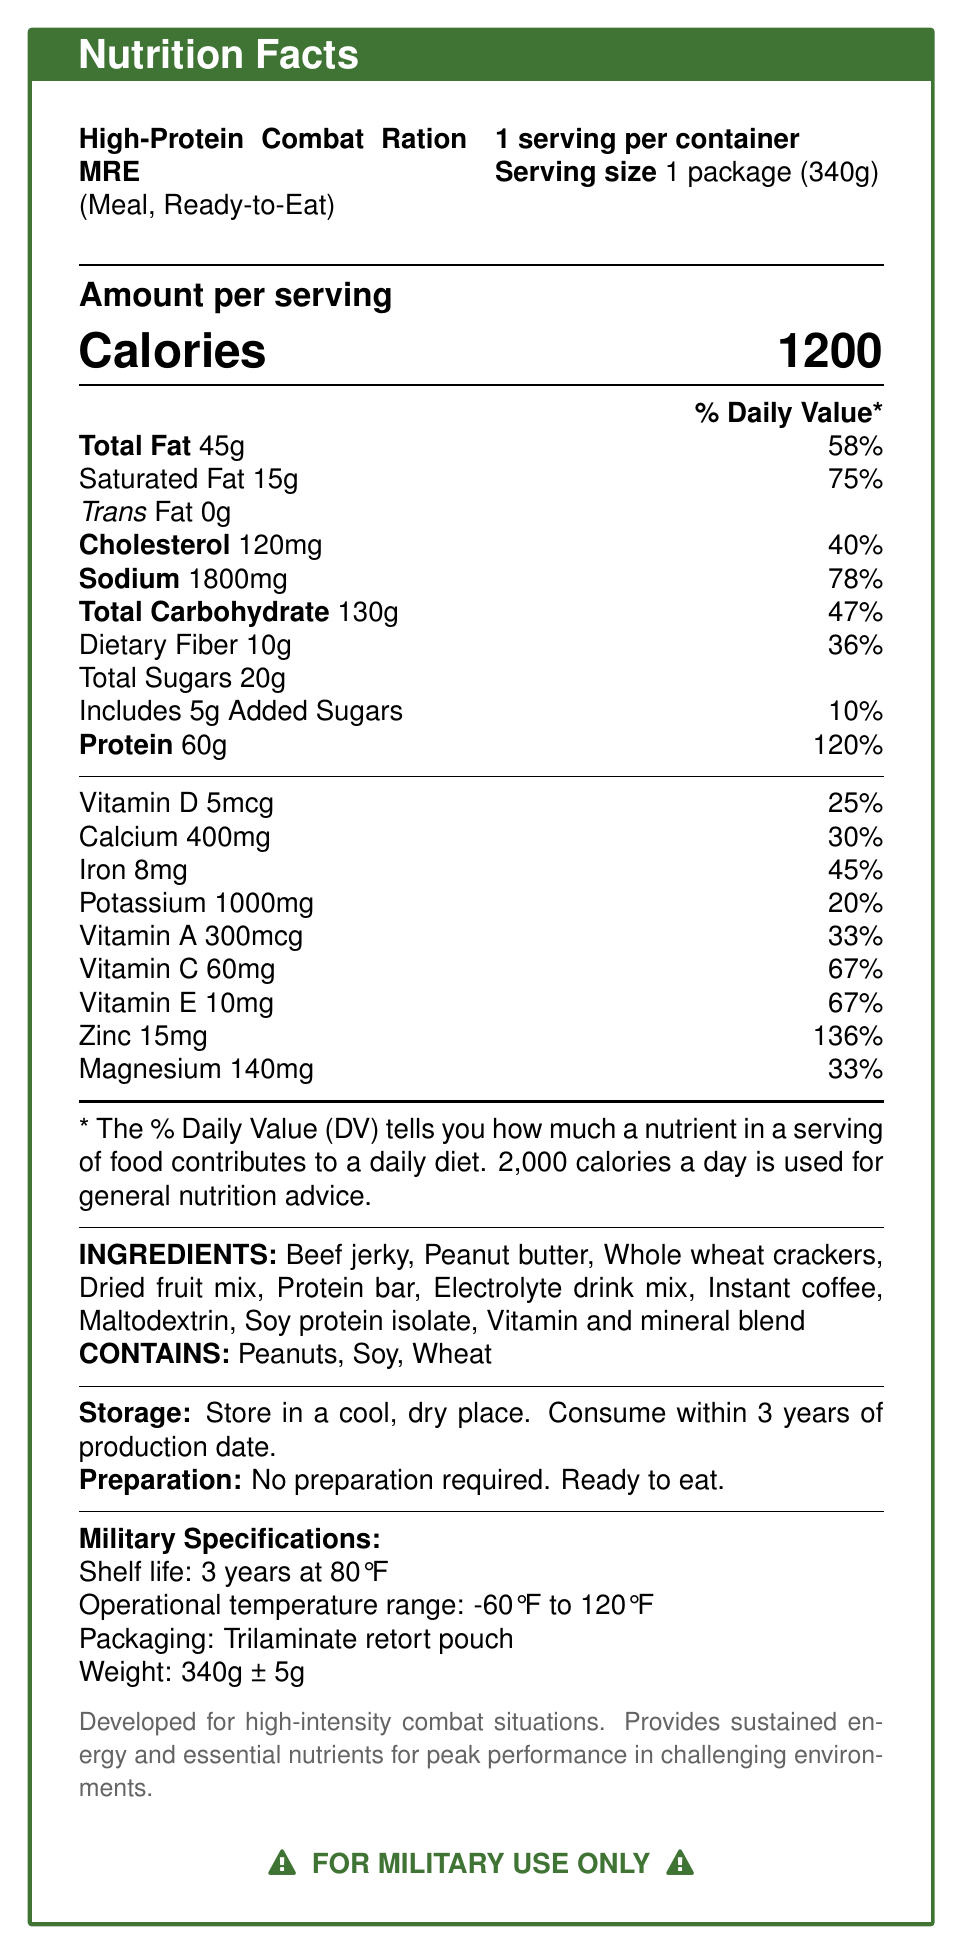what is the product name? The name of the product is explicitly mentioned at the top of the document.
Answer: High-Protein Combat Ration MRE (Meal, Ready-to-Eat) how many servings are there per container? The document states, "1 serving per container."
Answer: 1 how many calories are in one serving? The document indicates that there are 1200 calories per serving.
Answer: 1200 how much total fat is in the package? The document mentions "Total Fat 45g."
Answer: 45g what is the daily value percentage for iron? The document states, "Iron 8mg \hfill 45%."
Answer: 45% the product contains which allergens? A. Peanuts B. Soy C. Wheat D. All of the above The document lists "CONTAINS: Peanuts, Soy, Wheat."
Answer: D. All of the above what is the operational temperature range specified for this product? The document specifies that the operational temperature range is "-60°F to 120°F."
Answer: -60°F to 120°F how many grams of protein are in one serving? The document lists "Protein 60g."
Answer: 60g what ingredients are contained in the product? A. Beef jerky B. Dried fruit mix C. Maltodextrin D. All of the above The document lists the ingredients, which include "Beef jerky, Dried fruit mix, Maltodextrin."
Answer: D. All of the above what is the nutritional content of saturated fat in this product? A. 5g B. 15g C. 20g The document mentions "Saturated Fat 15g."
Answer: B. 15g does this product require any preparation? The document states, "No preparation required. Ready to eat."
Answer: No summarize the main idea of the document The document comprehensively lists the nutritional facts, ingredients, allergens, storage, preparation instructions, and specific military specifications for the product, focusing on its utility for military use in challenging environments.
Answer: The document provides detailed nutritional information, ingredients, allergens, storage, preparation instructions, and military specifications for a High-Protein Combat Ration MRE designed for high-intensity combat situations. what is the exact shelf life of the product? The document specifies, "Shelf life: 3 years at 80°F."
Answer: 3 years at 80°F how much potassium is in one serving? The document states, "Potassium 1000mg."
Answer: 1000mg is there an amount for trans fat specified in the document? The document mentions "Trans Fat 0g," implying that there is no trans fat in the product.
Answer: No what is the weight of the package? The document specifies the product weight as "340g ± 5g."
Answer: 340g ± 5g does the label include the production date? The document does not mention any details about the production date.
Answer: Not enough information 